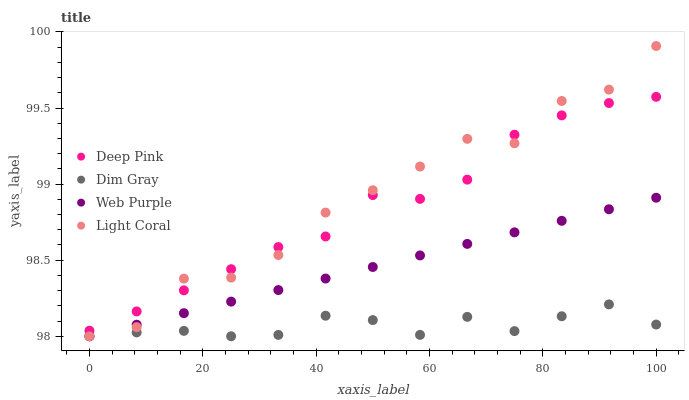Does Dim Gray have the minimum area under the curve?
Answer yes or no. Yes. Does Light Coral have the maximum area under the curve?
Answer yes or no. Yes. Does Deep Pink have the minimum area under the curve?
Answer yes or no. No. Does Deep Pink have the maximum area under the curve?
Answer yes or no. No. Is Web Purple the smoothest?
Answer yes or no. Yes. Is Light Coral the roughest?
Answer yes or no. Yes. Is Dim Gray the smoothest?
Answer yes or no. No. Is Dim Gray the roughest?
Answer yes or no. No. Does Light Coral have the lowest value?
Answer yes or no. Yes. Does Deep Pink have the lowest value?
Answer yes or no. No. Does Light Coral have the highest value?
Answer yes or no. Yes. Does Deep Pink have the highest value?
Answer yes or no. No. Is Dim Gray less than Deep Pink?
Answer yes or no. Yes. Is Deep Pink greater than Web Purple?
Answer yes or no. Yes. Does Web Purple intersect Dim Gray?
Answer yes or no. Yes. Is Web Purple less than Dim Gray?
Answer yes or no. No. Is Web Purple greater than Dim Gray?
Answer yes or no. No. Does Dim Gray intersect Deep Pink?
Answer yes or no. No. 